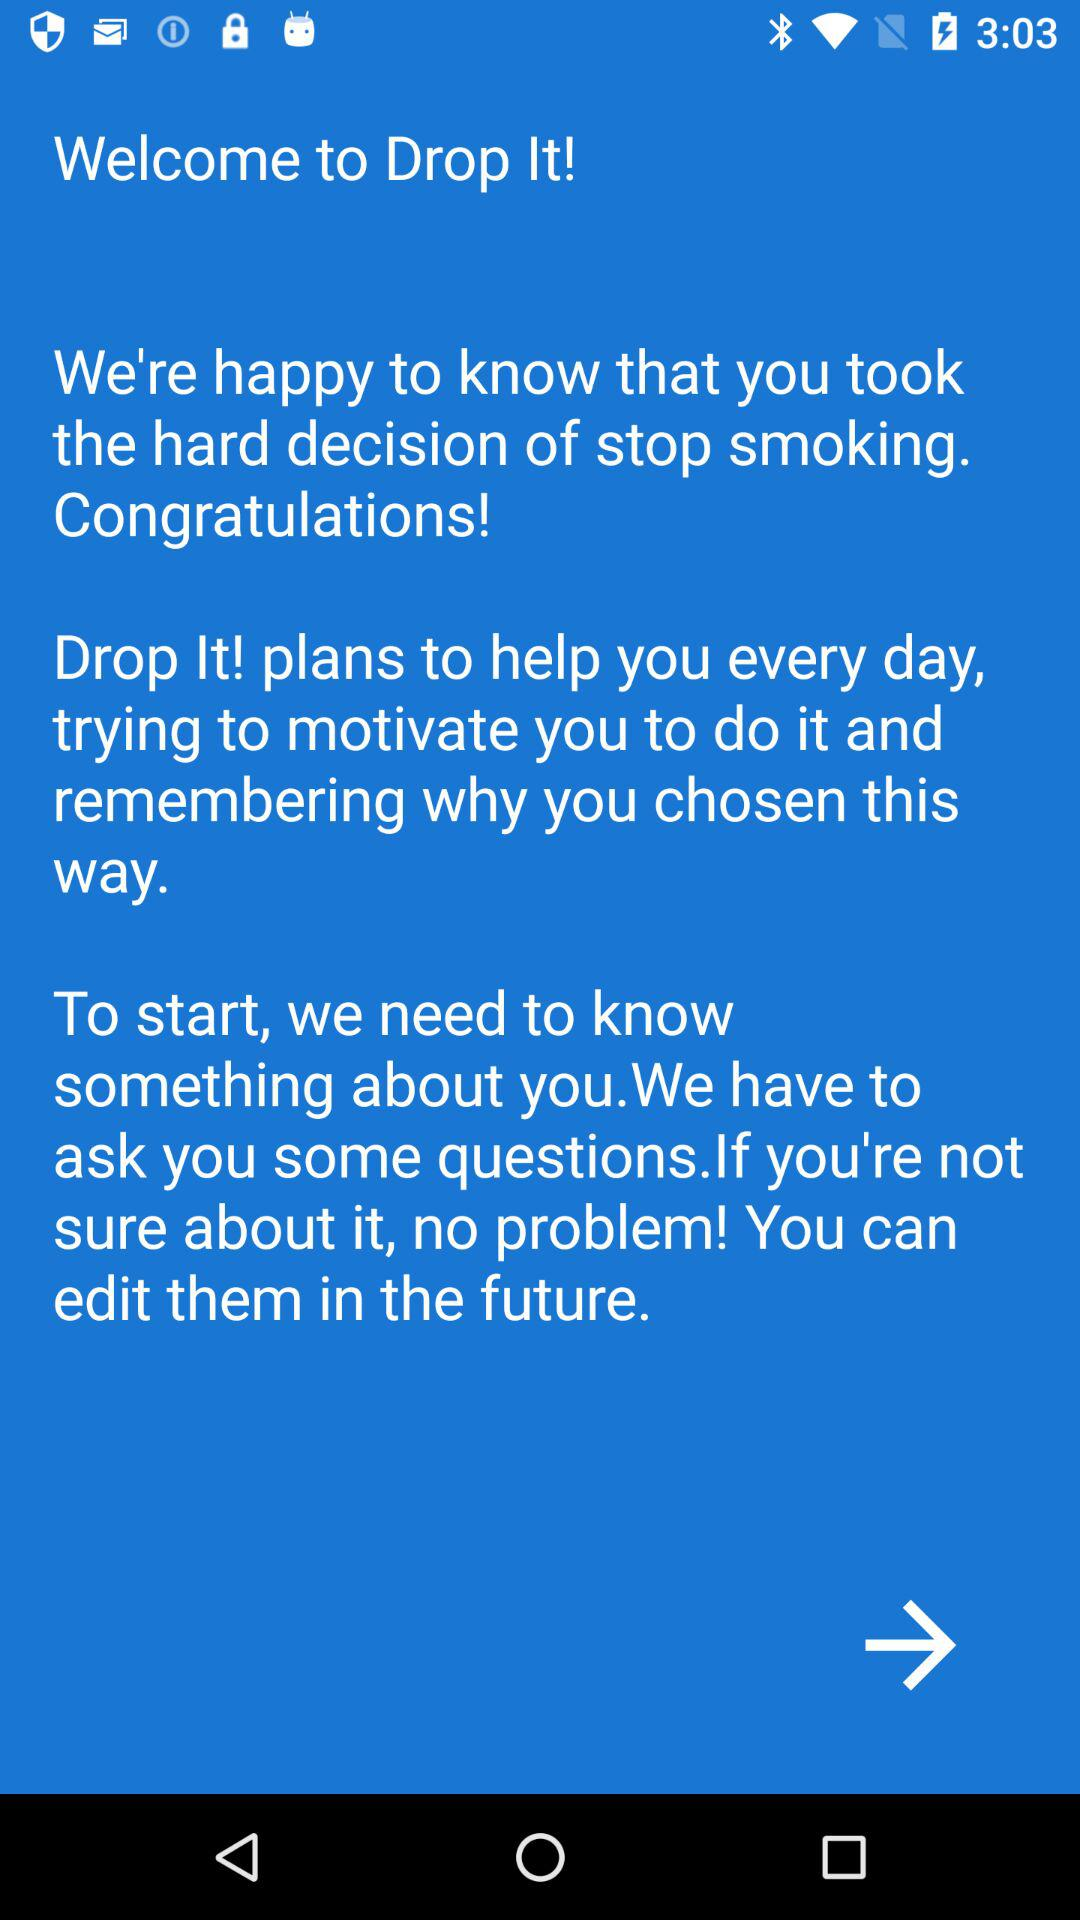What is the name of the application? The name of the application is "Drop It!". 